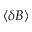<formula> <loc_0><loc_0><loc_500><loc_500>\langle \delta B \rangle</formula> 